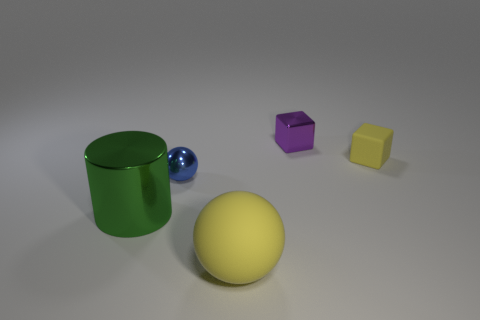What color is the rubber sphere that is the same size as the green cylinder?
Offer a very short reply. Yellow. There is a ball that is to the left of the big matte thing in front of the large cylinder; how big is it?
Provide a succinct answer. Small. What size is the other thing that is the same color as the small rubber thing?
Provide a short and direct response. Large. What number of other objects are the same size as the yellow rubber ball?
Offer a very short reply. 1. How many brown rubber cubes are there?
Your response must be concise. 0. Is the size of the purple block the same as the yellow rubber sphere?
Your answer should be compact. No. How many other objects are the same shape as the tiny purple object?
Your answer should be compact. 1. What material is the small yellow block that is right of the small shiny object that is behind the tiny sphere?
Ensure brevity in your answer.  Rubber. There is a blue metallic sphere; are there any purple blocks on the right side of it?
Provide a short and direct response. Yes. There is a green metallic cylinder; is its size the same as the ball that is in front of the green object?
Offer a very short reply. Yes. 